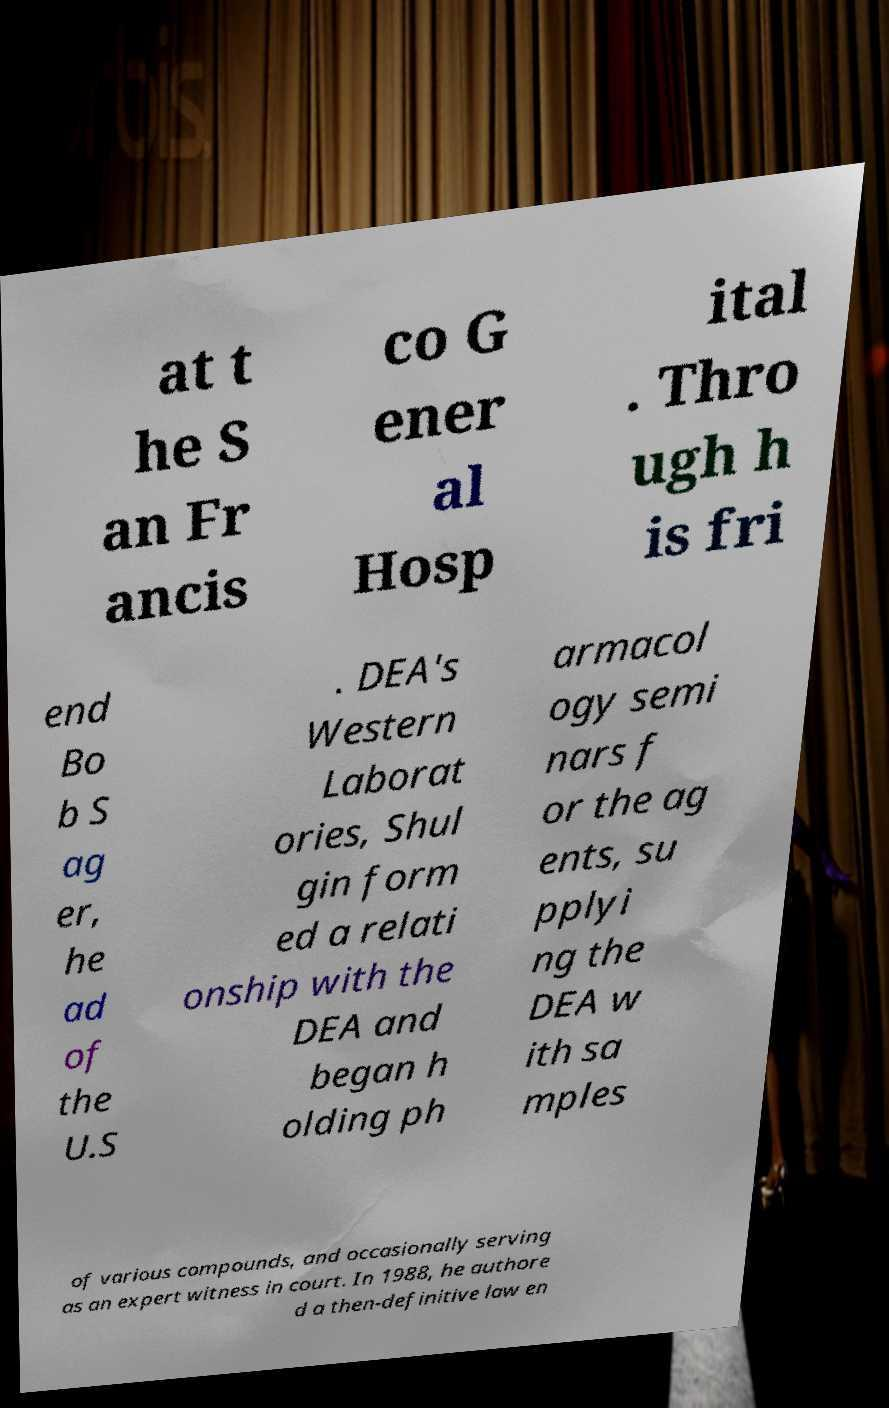For documentation purposes, I need the text within this image transcribed. Could you provide that? at t he S an Fr ancis co G ener al Hosp ital . Thro ugh h is fri end Bo b S ag er, he ad of the U.S . DEA's Western Laborat ories, Shul gin form ed a relati onship with the DEA and began h olding ph armacol ogy semi nars f or the ag ents, su pplyi ng the DEA w ith sa mples of various compounds, and occasionally serving as an expert witness in court. In 1988, he authore d a then-definitive law en 